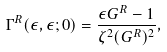Convert formula to latex. <formula><loc_0><loc_0><loc_500><loc_500>\Gamma ^ { R } ( \epsilon , \epsilon ; 0 ) = \frac { \epsilon G ^ { R } - 1 } { \zeta ^ { 2 } ( G ^ { R } ) ^ { 2 } } ,</formula> 